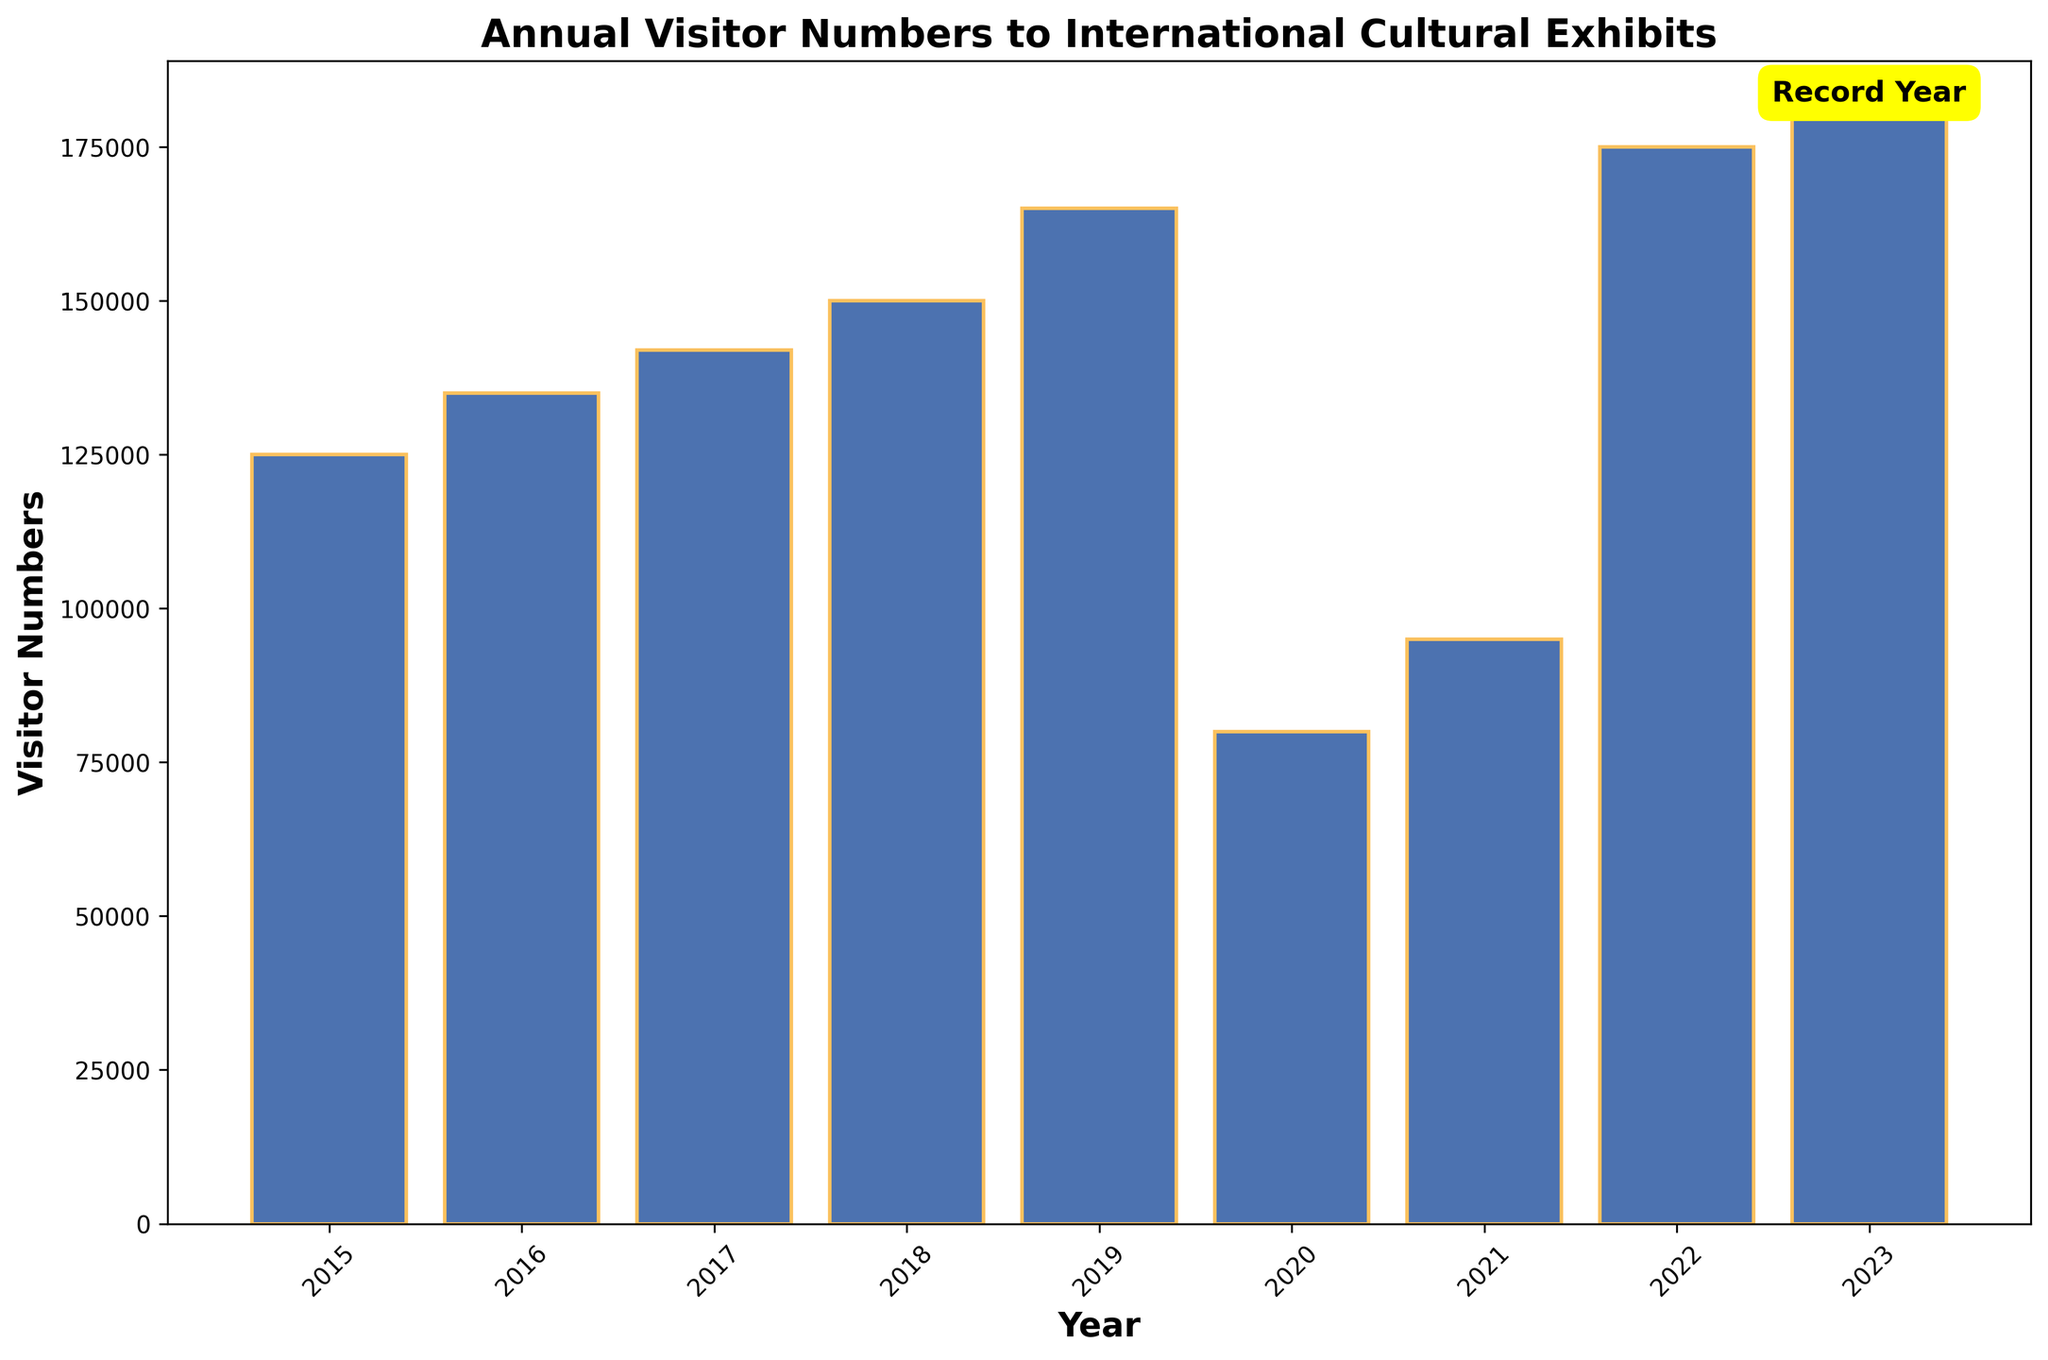What is the total number of visitors from 2015 to 2023? Sum the visitor numbers for each year: 125000 + 135000 + 142000 + 150000 + 165000 + 80000 + 95000 + 175000 + 180000 = 1241000
Answer: 1241000 In which year did the visitor numbers decrease the most compared to the previous year? Subtract the visitor numbers of each year from the previous year and identify the biggest decrease: 2019-2020: 165000 - 80000 = 85000 (the largest decrease)
Answer: 2020 What is the difference in visitor numbers between 2015 and the record year? Identify the record year (2023 with 180000 visitors), then subtract the visitor number of 2015 from 2023: 180000 - 125000 = 55000
Answer: 55000 Which years had fewer visitors than the record year? Compare each year's visitor numbers with the record year's (2023 with 180000 visitors). The years with fewer visitors are all years except 2023: 2015, 2016, 2017, 2018, 2019, 2020, 2021, 2022
Answer: 2015, 2016, 2017, 2018, 2019, 2020, 2021, 2022 How many years had visitor numbers above 150000? Count the number of years where visitor numbers are greater than 150000: 165000 (2019), 175000 (2022), 180000 (2023) - Total: 3 years
Answer: 3 What is the average visitor number from 2021 to 2023? Sum the visitor numbers for 2021 to 2023 and divide by 3: (95000 + 175000 + 180000) / 3 = 150000
Answer: 150000 Which year had the lowest visitor numbers? Look at the lowest bar in the chart, which corresponds to 2020 with 80000 visitors
Answer: 2020 What is the range of visitor numbers from 2015 to 2023? Subtract the smallest visitor number (80000 in 2020) from the largest visitor number (180000 in 2023): 180000 - 80000 = 100000
Answer: 100000 How does the visitor number in 2020 compare to 2019? Subtract the visitor number of 2020 from 2019: 165000 - 80000 = 85000 (decrease)
Answer: Decrease by 85000 Which year followed the first major increase (at least 10000 visitors) in visitor numbers? Identify the first year with an increase of at least 10000 visitors from the previous year: 2015-2016: 135000 - 125000 = 10000. So, the following year is of 2016
Answer: 2016 